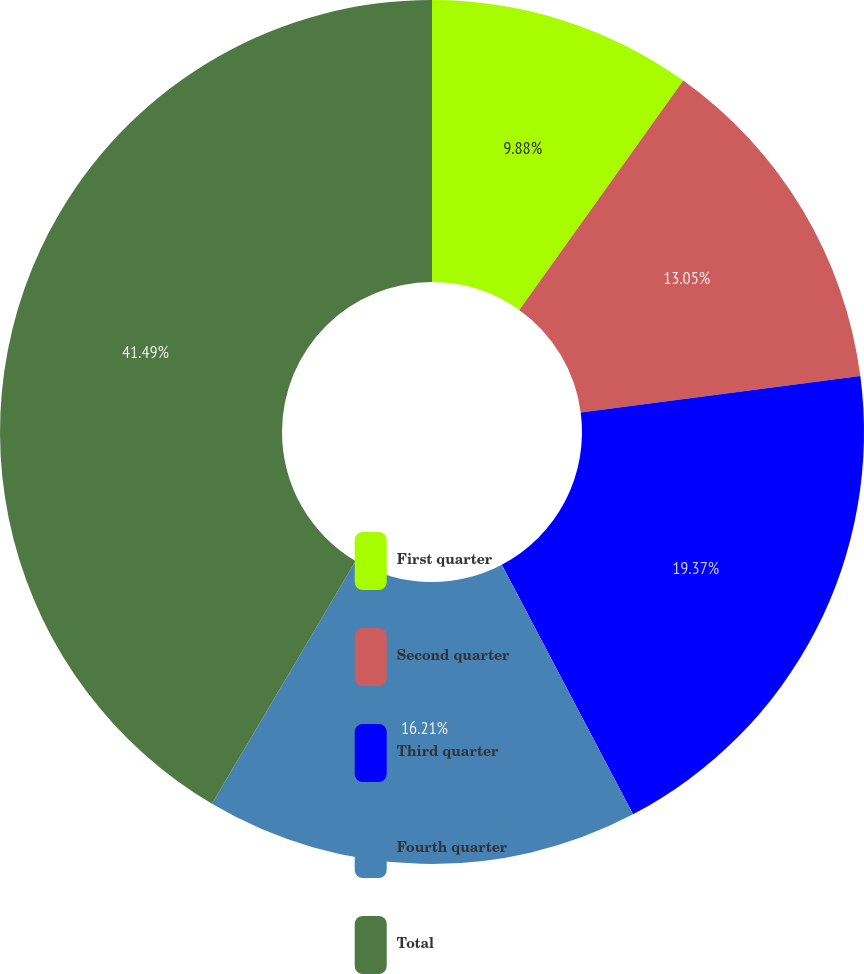Convert chart. <chart><loc_0><loc_0><loc_500><loc_500><pie_chart><fcel>First quarter<fcel>Second quarter<fcel>Third quarter<fcel>Fourth quarter<fcel>Total<nl><fcel>9.88%<fcel>13.05%<fcel>19.37%<fcel>16.21%<fcel>41.5%<nl></chart> 